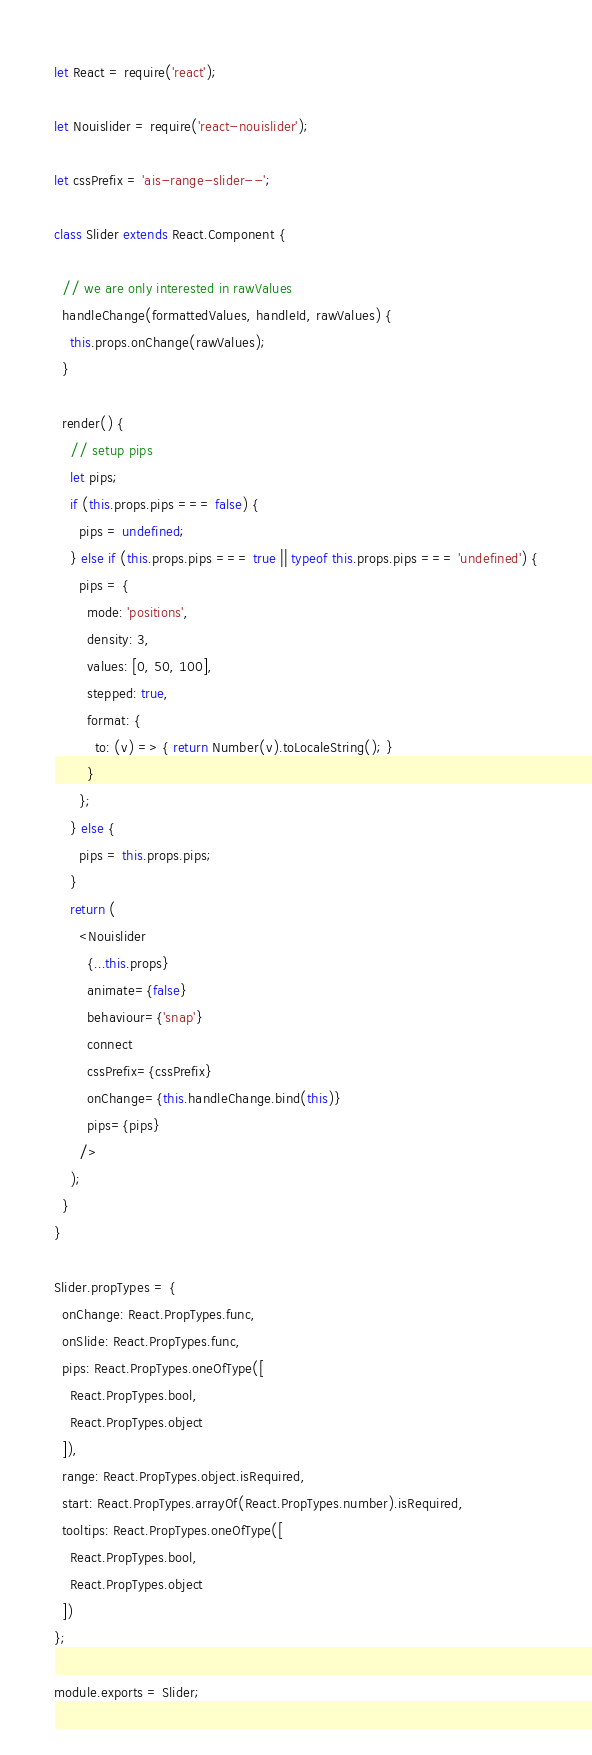<code> <loc_0><loc_0><loc_500><loc_500><_JavaScript_>let React = require('react');

let Nouislider = require('react-nouislider');

let cssPrefix = 'ais-range-slider--';

class Slider extends React.Component {

  // we are only interested in rawValues
  handleChange(formattedValues, handleId, rawValues) {
    this.props.onChange(rawValues);
  }

  render() {
    // setup pips
    let pips;
    if (this.props.pips === false) {
      pips = undefined;
    } else if (this.props.pips === true || typeof this.props.pips === 'undefined') {
      pips = {
        mode: 'positions',
        density: 3,
        values: [0, 50, 100],
        stepped: true,
        format: {
          to: (v) => { return Number(v).toLocaleString(); }
        }
      };
    } else {
      pips = this.props.pips;
    }
    return (
      <Nouislider
        {...this.props}
        animate={false}
        behaviour={'snap'}
        connect
        cssPrefix={cssPrefix}
        onChange={this.handleChange.bind(this)}
        pips={pips}
      />
    );
  }
}

Slider.propTypes = {
  onChange: React.PropTypes.func,
  onSlide: React.PropTypes.func,
  pips: React.PropTypes.oneOfType([
    React.PropTypes.bool,
    React.PropTypes.object
  ]),
  range: React.PropTypes.object.isRequired,
  start: React.PropTypes.arrayOf(React.PropTypes.number).isRequired,
  tooltips: React.PropTypes.oneOfType([
    React.PropTypes.bool,
    React.PropTypes.object
  ])
};

module.exports = Slider;
</code> 